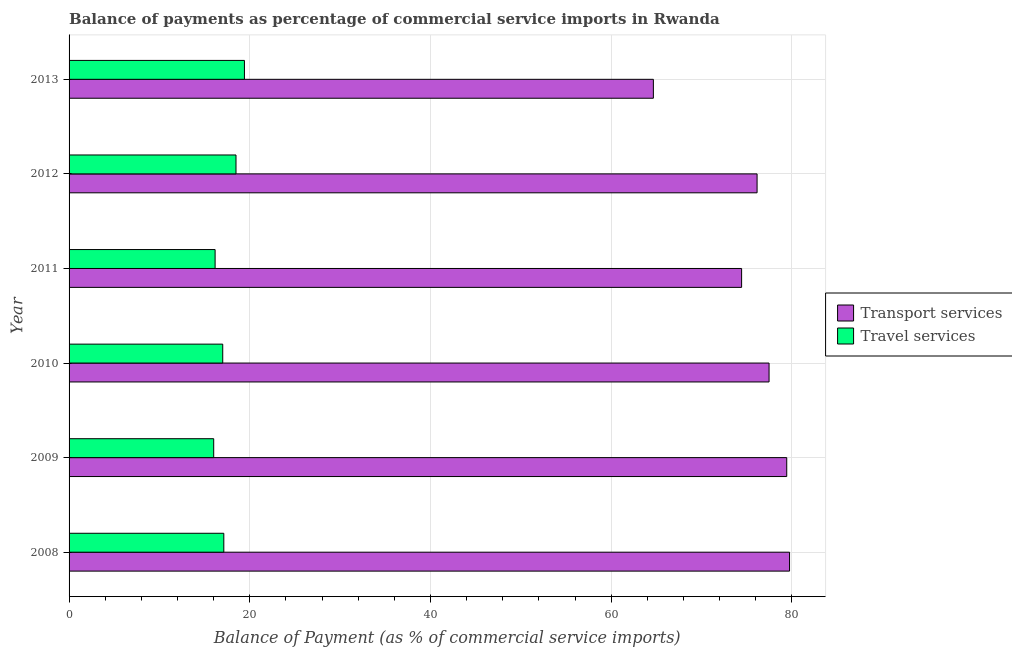How many groups of bars are there?
Provide a succinct answer. 6. Are the number of bars on each tick of the Y-axis equal?
Your response must be concise. Yes. How many bars are there on the 4th tick from the bottom?
Your response must be concise. 2. What is the label of the 5th group of bars from the top?
Give a very brief answer. 2009. In how many cases, is the number of bars for a given year not equal to the number of legend labels?
Provide a succinct answer. 0. What is the balance of payments of transport services in 2011?
Provide a short and direct response. 74.44. Across all years, what is the maximum balance of payments of transport services?
Your response must be concise. 79.75. Across all years, what is the minimum balance of payments of transport services?
Offer a very short reply. 64.68. In which year was the balance of payments of transport services maximum?
Your answer should be very brief. 2008. What is the total balance of payments of transport services in the graph?
Offer a terse response. 451.94. What is the difference between the balance of payments of transport services in 2012 and that in 2013?
Offer a very short reply. 11.48. What is the difference between the balance of payments of transport services in 2011 and the balance of payments of travel services in 2008?
Give a very brief answer. 57.31. What is the average balance of payments of travel services per year?
Make the answer very short. 17.37. In the year 2009, what is the difference between the balance of payments of travel services and balance of payments of transport services?
Keep it short and to the point. -63.43. In how many years, is the balance of payments of transport services greater than 4 %?
Offer a terse response. 6. What is the ratio of the balance of payments of travel services in 2010 to that in 2012?
Give a very brief answer. 0.92. What is the difference between the highest and the second highest balance of payments of transport services?
Ensure brevity in your answer.  0.31. What is the difference between the highest and the lowest balance of payments of transport services?
Ensure brevity in your answer.  15.07. In how many years, is the balance of payments of travel services greater than the average balance of payments of travel services taken over all years?
Offer a terse response. 2. What does the 2nd bar from the top in 2012 represents?
Provide a succinct answer. Transport services. What does the 1st bar from the bottom in 2011 represents?
Your answer should be very brief. Transport services. Are all the bars in the graph horizontal?
Offer a terse response. Yes. What is the difference between two consecutive major ticks on the X-axis?
Offer a very short reply. 20. Does the graph contain any zero values?
Give a very brief answer. No. Does the graph contain grids?
Offer a terse response. Yes. Where does the legend appear in the graph?
Your answer should be compact. Center right. What is the title of the graph?
Your answer should be compact. Balance of payments as percentage of commercial service imports in Rwanda. What is the label or title of the X-axis?
Offer a very short reply. Balance of Payment (as % of commercial service imports). What is the Balance of Payment (as % of commercial service imports) of Transport services in 2008?
Ensure brevity in your answer.  79.75. What is the Balance of Payment (as % of commercial service imports) of Travel services in 2008?
Give a very brief answer. 17.13. What is the Balance of Payment (as % of commercial service imports) in Transport services in 2009?
Make the answer very short. 79.44. What is the Balance of Payment (as % of commercial service imports) of Travel services in 2009?
Offer a very short reply. 16.01. What is the Balance of Payment (as % of commercial service imports) of Transport services in 2010?
Offer a very short reply. 77.48. What is the Balance of Payment (as % of commercial service imports) in Travel services in 2010?
Your answer should be compact. 17.01. What is the Balance of Payment (as % of commercial service imports) in Transport services in 2011?
Provide a short and direct response. 74.44. What is the Balance of Payment (as % of commercial service imports) in Travel services in 2011?
Provide a succinct answer. 16.16. What is the Balance of Payment (as % of commercial service imports) in Transport services in 2012?
Your answer should be compact. 76.15. What is the Balance of Payment (as % of commercial service imports) in Travel services in 2012?
Provide a succinct answer. 18.48. What is the Balance of Payment (as % of commercial service imports) of Transport services in 2013?
Keep it short and to the point. 64.68. What is the Balance of Payment (as % of commercial service imports) of Travel services in 2013?
Provide a short and direct response. 19.41. Across all years, what is the maximum Balance of Payment (as % of commercial service imports) in Transport services?
Your answer should be compact. 79.75. Across all years, what is the maximum Balance of Payment (as % of commercial service imports) in Travel services?
Your response must be concise. 19.41. Across all years, what is the minimum Balance of Payment (as % of commercial service imports) in Transport services?
Provide a succinct answer. 64.68. Across all years, what is the minimum Balance of Payment (as % of commercial service imports) in Travel services?
Your response must be concise. 16.01. What is the total Balance of Payment (as % of commercial service imports) of Transport services in the graph?
Provide a succinct answer. 451.94. What is the total Balance of Payment (as % of commercial service imports) of Travel services in the graph?
Provide a short and direct response. 104.2. What is the difference between the Balance of Payment (as % of commercial service imports) in Transport services in 2008 and that in 2009?
Provide a succinct answer. 0.31. What is the difference between the Balance of Payment (as % of commercial service imports) in Travel services in 2008 and that in 2009?
Your response must be concise. 1.12. What is the difference between the Balance of Payment (as % of commercial service imports) of Transport services in 2008 and that in 2010?
Your response must be concise. 2.27. What is the difference between the Balance of Payment (as % of commercial service imports) of Travel services in 2008 and that in 2010?
Your response must be concise. 0.12. What is the difference between the Balance of Payment (as % of commercial service imports) of Transport services in 2008 and that in 2011?
Keep it short and to the point. 5.31. What is the difference between the Balance of Payment (as % of commercial service imports) in Travel services in 2008 and that in 2011?
Ensure brevity in your answer.  0.96. What is the difference between the Balance of Payment (as % of commercial service imports) in Transport services in 2008 and that in 2012?
Your response must be concise. 3.59. What is the difference between the Balance of Payment (as % of commercial service imports) of Travel services in 2008 and that in 2012?
Offer a very short reply. -1.35. What is the difference between the Balance of Payment (as % of commercial service imports) of Transport services in 2008 and that in 2013?
Ensure brevity in your answer.  15.07. What is the difference between the Balance of Payment (as % of commercial service imports) of Travel services in 2008 and that in 2013?
Make the answer very short. -2.28. What is the difference between the Balance of Payment (as % of commercial service imports) of Transport services in 2009 and that in 2010?
Offer a terse response. 1.96. What is the difference between the Balance of Payment (as % of commercial service imports) in Travel services in 2009 and that in 2010?
Your answer should be compact. -1. What is the difference between the Balance of Payment (as % of commercial service imports) in Transport services in 2009 and that in 2011?
Keep it short and to the point. 4.99. What is the difference between the Balance of Payment (as % of commercial service imports) of Travel services in 2009 and that in 2011?
Ensure brevity in your answer.  -0.16. What is the difference between the Balance of Payment (as % of commercial service imports) of Transport services in 2009 and that in 2012?
Your response must be concise. 3.28. What is the difference between the Balance of Payment (as % of commercial service imports) in Travel services in 2009 and that in 2012?
Your response must be concise. -2.47. What is the difference between the Balance of Payment (as % of commercial service imports) in Transport services in 2009 and that in 2013?
Provide a succinct answer. 14.76. What is the difference between the Balance of Payment (as % of commercial service imports) of Travel services in 2009 and that in 2013?
Your answer should be compact. -3.4. What is the difference between the Balance of Payment (as % of commercial service imports) of Transport services in 2010 and that in 2011?
Offer a terse response. 3.04. What is the difference between the Balance of Payment (as % of commercial service imports) in Travel services in 2010 and that in 2011?
Ensure brevity in your answer.  0.84. What is the difference between the Balance of Payment (as % of commercial service imports) of Transport services in 2010 and that in 2012?
Ensure brevity in your answer.  1.33. What is the difference between the Balance of Payment (as % of commercial service imports) in Travel services in 2010 and that in 2012?
Provide a succinct answer. -1.47. What is the difference between the Balance of Payment (as % of commercial service imports) of Transport services in 2010 and that in 2013?
Ensure brevity in your answer.  12.81. What is the difference between the Balance of Payment (as % of commercial service imports) in Travel services in 2010 and that in 2013?
Your answer should be very brief. -2.4. What is the difference between the Balance of Payment (as % of commercial service imports) in Transport services in 2011 and that in 2012?
Offer a very short reply. -1.71. What is the difference between the Balance of Payment (as % of commercial service imports) in Travel services in 2011 and that in 2012?
Give a very brief answer. -2.31. What is the difference between the Balance of Payment (as % of commercial service imports) of Transport services in 2011 and that in 2013?
Provide a succinct answer. 9.77. What is the difference between the Balance of Payment (as % of commercial service imports) of Travel services in 2011 and that in 2013?
Keep it short and to the point. -3.25. What is the difference between the Balance of Payment (as % of commercial service imports) of Transport services in 2012 and that in 2013?
Keep it short and to the point. 11.48. What is the difference between the Balance of Payment (as % of commercial service imports) of Travel services in 2012 and that in 2013?
Keep it short and to the point. -0.93. What is the difference between the Balance of Payment (as % of commercial service imports) in Transport services in 2008 and the Balance of Payment (as % of commercial service imports) in Travel services in 2009?
Offer a very short reply. 63.74. What is the difference between the Balance of Payment (as % of commercial service imports) of Transport services in 2008 and the Balance of Payment (as % of commercial service imports) of Travel services in 2010?
Provide a succinct answer. 62.74. What is the difference between the Balance of Payment (as % of commercial service imports) of Transport services in 2008 and the Balance of Payment (as % of commercial service imports) of Travel services in 2011?
Make the answer very short. 63.58. What is the difference between the Balance of Payment (as % of commercial service imports) of Transport services in 2008 and the Balance of Payment (as % of commercial service imports) of Travel services in 2012?
Give a very brief answer. 61.27. What is the difference between the Balance of Payment (as % of commercial service imports) in Transport services in 2008 and the Balance of Payment (as % of commercial service imports) in Travel services in 2013?
Keep it short and to the point. 60.34. What is the difference between the Balance of Payment (as % of commercial service imports) in Transport services in 2009 and the Balance of Payment (as % of commercial service imports) in Travel services in 2010?
Offer a very short reply. 62.43. What is the difference between the Balance of Payment (as % of commercial service imports) in Transport services in 2009 and the Balance of Payment (as % of commercial service imports) in Travel services in 2011?
Keep it short and to the point. 63.27. What is the difference between the Balance of Payment (as % of commercial service imports) of Transport services in 2009 and the Balance of Payment (as % of commercial service imports) of Travel services in 2012?
Offer a terse response. 60.96. What is the difference between the Balance of Payment (as % of commercial service imports) of Transport services in 2009 and the Balance of Payment (as % of commercial service imports) of Travel services in 2013?
Your answer should be compact. 60.03. What is the difference between the Balance of Payment (as % of commercial service imports) of Transport services in 2010 and the Balance of Payment (as % of commercial service imports) of Travel services in 2011?
Provide a succinct answer. 61.32. What is the difference between the Balance of Payment (as % of commercial service imports) in Transport services in 2010 and the Balance of Payment (as % of commercial service imports) in Travel services in 2012?
Ensure brevity in your answer.  59. What is the difference between the Balance of Payment (as % of commercial service imports) of Transport services in 2010 and the Balance of Payment (as % of commercial service imports) of Travel services in 2013?
Give a very brief answer. 58.07. What is the difference between the Balance of Payment (as % of commercial service imports) of Transport services in 2011 and the Balance of Payment (as % of commercial service imports) of Travel services in 2012?
Your answer should be very brief. 55.97. What is the difference between the Balance of Payment (as % of commercial service imports) of Transport services in 2011 and the Balance of Payment (as % of commercial service imports) of Travel services in 2013?
Your answer should be very brief. 55.03. What is the difference between the Balance of Payment (as % of commercial service imports) in Transport services in 2012 and the Balance of Payment (as % of commercial service imports) in Travel services in 2013?
Offer a terse response. 56.74. What is the average Balance of Payment (as % of commercial service imports) in Transport services per year?
Ensure brevity in your answer.  75.32. What is the average Balance of Payment (as % of commercial service imports) of Travel services per year?
Keep it short and to the point. 17.37. In the year 2008, what is the difference between the Balance of Payment (as % of commercial service imports) in Transport services and Balance of Payment (as % of commercial service imports) in Travel services?
Offer a terse response. 62.62. In the year 2009, what is the difference between the Balance of Payment (as % of commercial service imports) in Transport services and Balance of Payment (as % of commercial service imports) in Travel services?
Offer a terse response. 63.43. In the year 2010, what is the difference between the Balance of Payment (as % of commercial service imports) in Transport services and Balance of Payment (as % of commercial service imports) in Travel services?
Ensure brevity in your answer.  60.47. In the year 2011, what is the difference between the Balance of Payment (as % of commercial service imports) in Transport services and Balance of Payment (as % of commercial service imports) in Travel services?
Your answer should be very brief. 58.28. In the year 2012, what is the difference between the Balance of Payment (as % of commercial service imports) of Transport services and Balance of Payment (as % of commercial service imports) of Travel services?
Offer a terse response. 57.68. In the year 2013, what is the difference between the Balance of Payment (as % of commercial service imports) of Transport services and Balance of Payment (as % of commercial service imports) of Travel services?
Keep it short and to the point. 45.26. What is the ratio of the Balance of Payment (as % of commercial service imports) of Transport services in 2008 to that in 2009?
Your answer should be compact. 1. What is the ratio of the Balance of Payment (as % of commercial service imports) in Travel services in 2008 to that in 2009?
Keep it short and to the point. 1.07. What is the ratio of the Balance of Payment (as % of commercial service imports) in Transport services in 2008 to that in 2010?
Offer a terse response. 1.03. What is the ratio of the Balance of Payment (as % of commercial service imports) in Travel services in 2008 to that in 2010?
Your answer should be very brief. 1.01. What is the ratio of the Balance of Payment (as % of commercial service imports) of Transport services in 2008 to that in 2011?
Ensure brevity in your answer.  1.07. What is the ratio of the Balance of Payment (as % of commercial service imports) in Travel services in 2008 to that in 2011?
Offer a very short reply. 1.06. What is the ratio of the Balance of Payment (as % of commercial service imports) in Transport services in 2008 to that in 2012?
Give a very brief answer. 1.05. What is the ratio of the Balance of Payment (as % of commercial service imports) of Travel services in 2008 to that in 2012?
Offer a terse response. 0.93. What is the ratio of the Balance of Payment (as % of commercial service imports) in Transport services in 2008 to that in 2013?
Your answer should be compact. 1.23. What is the ratio of the Balance of Payment (as % of commercial service imports) in Travel services in 2008 to that in 2013?
Make the answer very short. 0.88. What is the ratio of the Balance of Payment (as % of commercial service imports) in Transport services in 2009 to that in 2010?
Make the answer very short. 1.03. What is the ratio of the Balance of Payment (as % of commercial service imports) of Travel services in 2009 to that in 2010?
Keep it short and to the point. 0.94. What is the ratio of the Balance of Payment (as % of commercial service imports) in Transport services in 2009 to that in 2011?
Your response must be concise. 1.07. What is the ratio of the Balance of Payment (as % of commercial service imports) of Transport services in 2009 to that in 2012?
Your response must be concise. 1.04. What is the ratio of the Balance of Payment (as % of commercial service imports) of Travel services in 2009 to that in 2012?
Offer a very short reply. 0.87. What is the ratio of the Balance of Payment (as % of commercial service imports) of Transport services in 2009 to that in 2013?
Provide a succinct answer. 1.23. What is the ratio of the Balance of Payment (as % of commercial service imports) in Travel services in 2009 to that in 2013?
Provide a succinct answer. 0.82. What is the ratio of the Balance of Payment (as % of commercial service imports) of Transport services in 2010 to that in 2011?
Your answer should be compact. 1.04. What is the ratio of the Balance of Payment (as % of commercial service imports) in Travel services in 2010 to that in 2011?
Your response must be concise. 1.05. What is the ratio of the Balance of Payment (as % of commercial service imports) of Transport services in 2010 to that in 2012?
Make the answer very short. 1.02. What is the ratio of the Balance of Payment (as % of commercial service imports) in Travel services in 2010 to that in 2012?
Give a very brief answer. 0.92. What is the ratio of the Balance of Payment (as % of commercial service imports) in Transport services in 2010 to that in 2013?
Give a very brief answer. 1.2. What is the ratio of the Balance of Payment (as % of commercial service imports) in Travel services in 2010 to that in 2013?
Make the answer very short. 0.88. What is the ratio of the Balance of Payment (as % of commercial service imports) in Transport services in 2011 to that in 2012?
Offer a very short reply. 0.98. What is the ratio of the Balance of Payment (as % of commercial service imports) in Travel services in 2011 to that in 2012?
Keep it short and to the point. 0.87. What is the ratio of the Balance of Payment (as % of commercial service imports) of Transport services in 2011 to that in 2013?
Give a very brief answer. 1.15. What is the ratio of the Balance of Payment (as % of commercial service imports) of Travel services in 2011 to that in 2013?
Your answer should be very brief. 0.83. What is the ratio of the Balance of Payment (as % of commercial service imports) in Transport services in 2012 to that in 2013?
Offer a very short reply. 1.18. What is the ratio of the Balance of Payment (as % of commercial service imports) in Travel services in 2012 to that in 2013?
Keep it short and to the point. 0.95. What is the difference between the highest and the second highest Balance of Payment (as % of commercial service imports) in Transport services?
Ensure brevity in your answer.  0.31. What is the difference between the highest and the second highest Balance of Payment (as % of commercial service imports) of Travel services?
Ensure brevity in your answer.  0.93. What is the difference between the highest and the lowest Balance of Payment (as % of commercial service imports) in Transport services?
Make the answer very short. 15.07. What is the difference between the highest and the lowest Balance of Payment (as % of commercial service imports) of Travel services?
Keep it short and to the point. 3.4. 